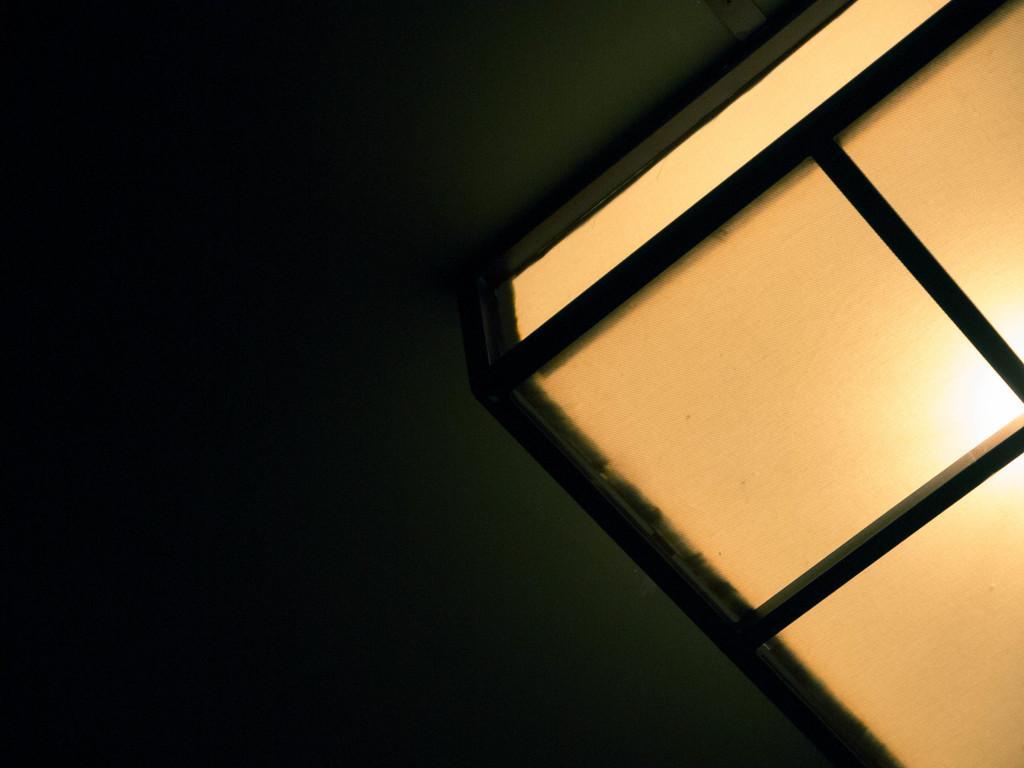Could you give a brief overview of what you see in this image? In this picture there is a light on the right side of the image. On the left side of the image there is a dark green background. 